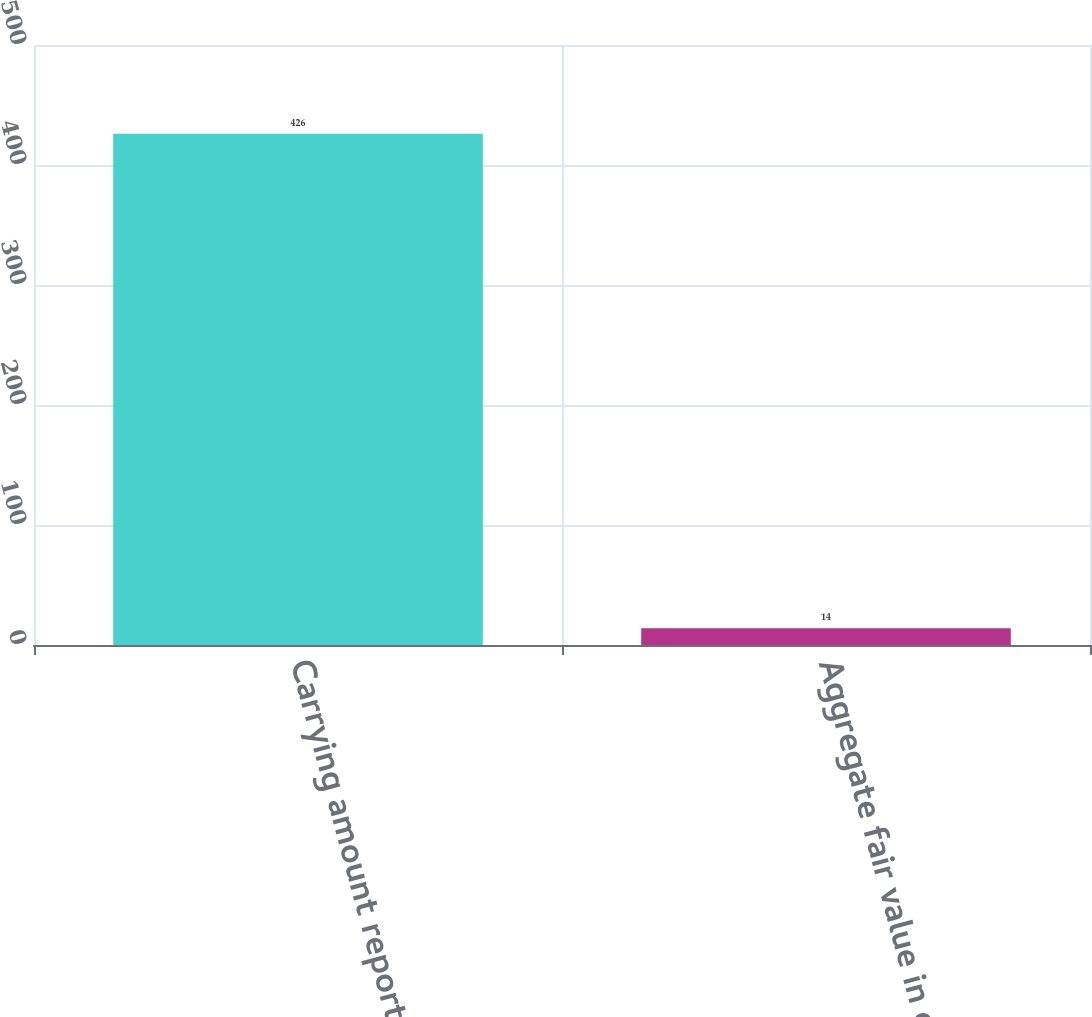Convert chart. <chart><loc_0><loc_0><loc_500><loc_500><bar_chart><fcel>Carrying amount reported on<fcel>Aggregate fair value in excess<nl><fcel>426<fcel>14<nl></chart> 